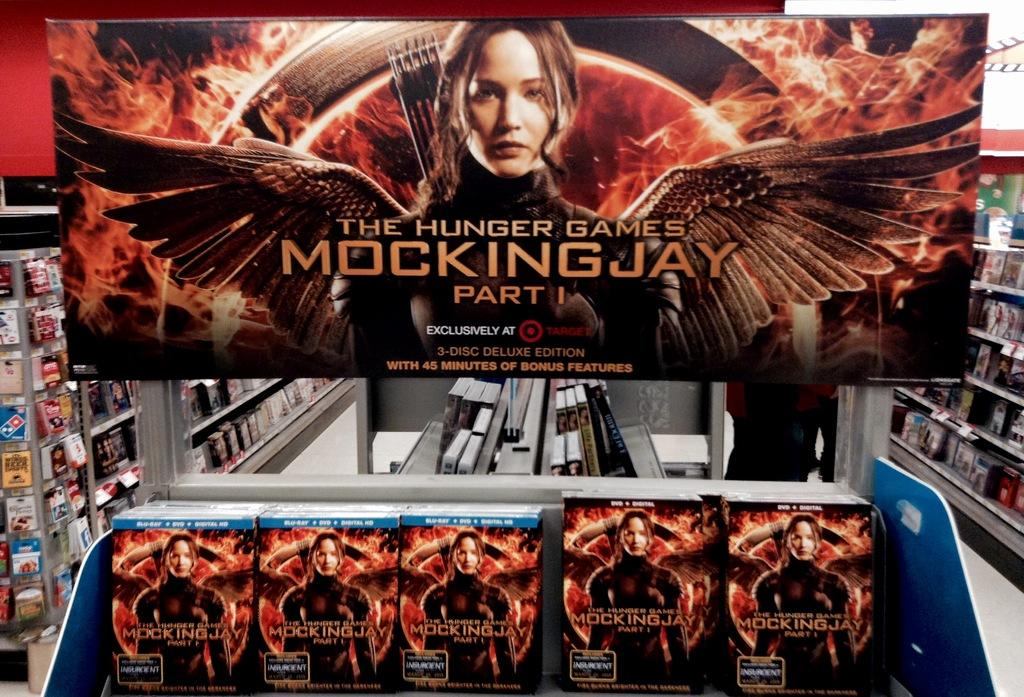Provide a one-sentence caption for the provided image. A movie display with DVD's of The Hunger Games Mockingjay according to the billboard above the DVD's. 